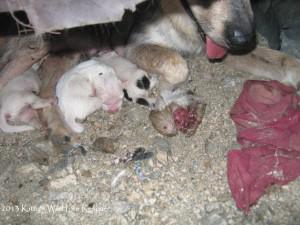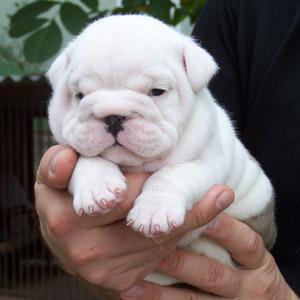The first image is the image on the left, the second image is the image on the right. Analyze the images presented: Is the assertion "The right image contains an adult dog nursing her puppies." valid? Answer yes or no. No. 